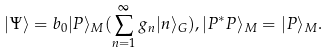Convert formula to latex. <formula><loc_0><loc_0><loc_500><loc_500>| \Psi \rangle = b _ { 0 } | P \rangle _ { M } ( \sum _ { n = 1 } ^ { \infty } g _ { n } | n \rangle _ { G } ) , | P ^ { * } P \rangle _ { M } = | P \rangle _ { M } .</formula> 